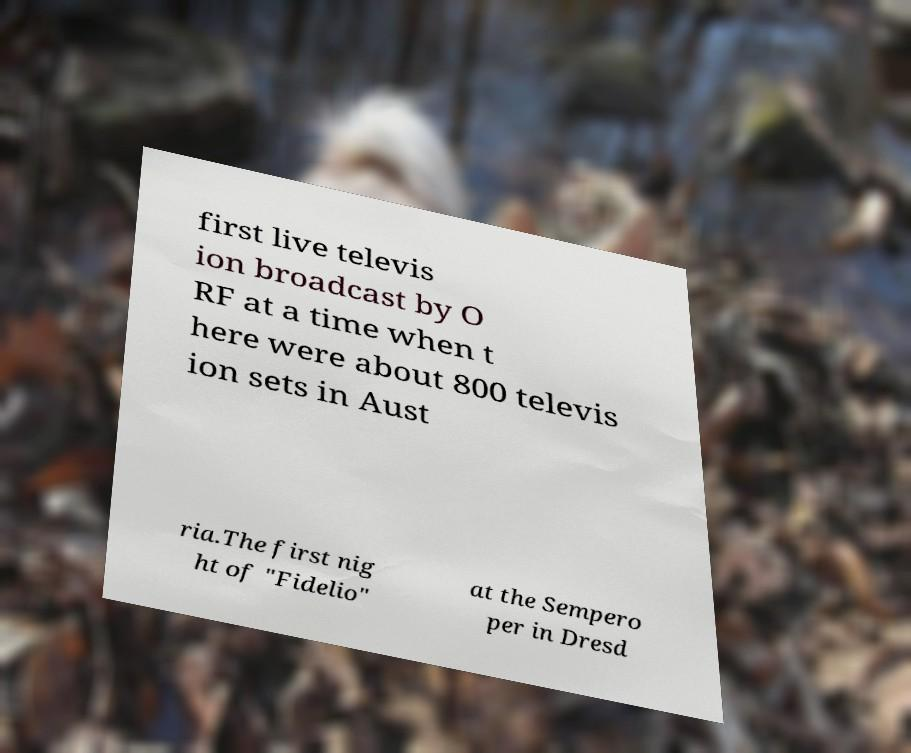Please read and relay the text visible in this image. What does it say? first live televis ion broadcast by O RF at a time when t here were about 800 televis ion sets in Aust ria.The first nig ht of "Fidelio" at the Sempero per in Dresd 